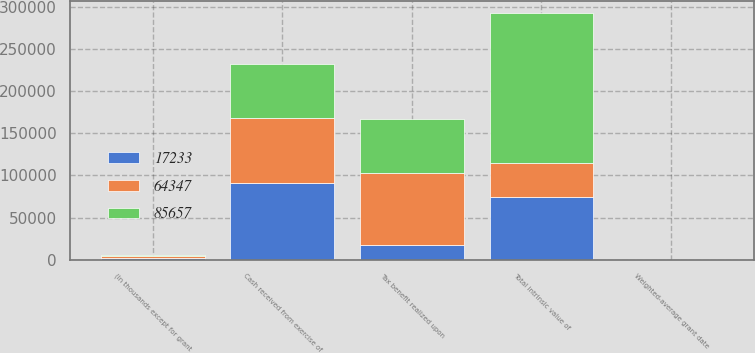Convert chart to OTSL. <chart><loc_0><loc_0><loc_500><loc_500><stacked_bar_chart><ecel><fcel>(In thousands except for grant<fcel>Weighted-average grant date<fcel>Total intrinsic value of<fcel>Cash received from exercise of<fcel>Tax benefit realized upon<nl><fcel>17233<fcel>2018<fcel>20.13<fcel>74530<fcel>91349<fcel>17233<nl><fcel>64347<fcel>2017<fcel>20.5<fcel>40513.5<fcel>76705<fcel>85657<nl><fcel>85657<fcel>2016<fcel>18.31<fcel>177375<fcel>63794<fcel>64347<nl></chart> 